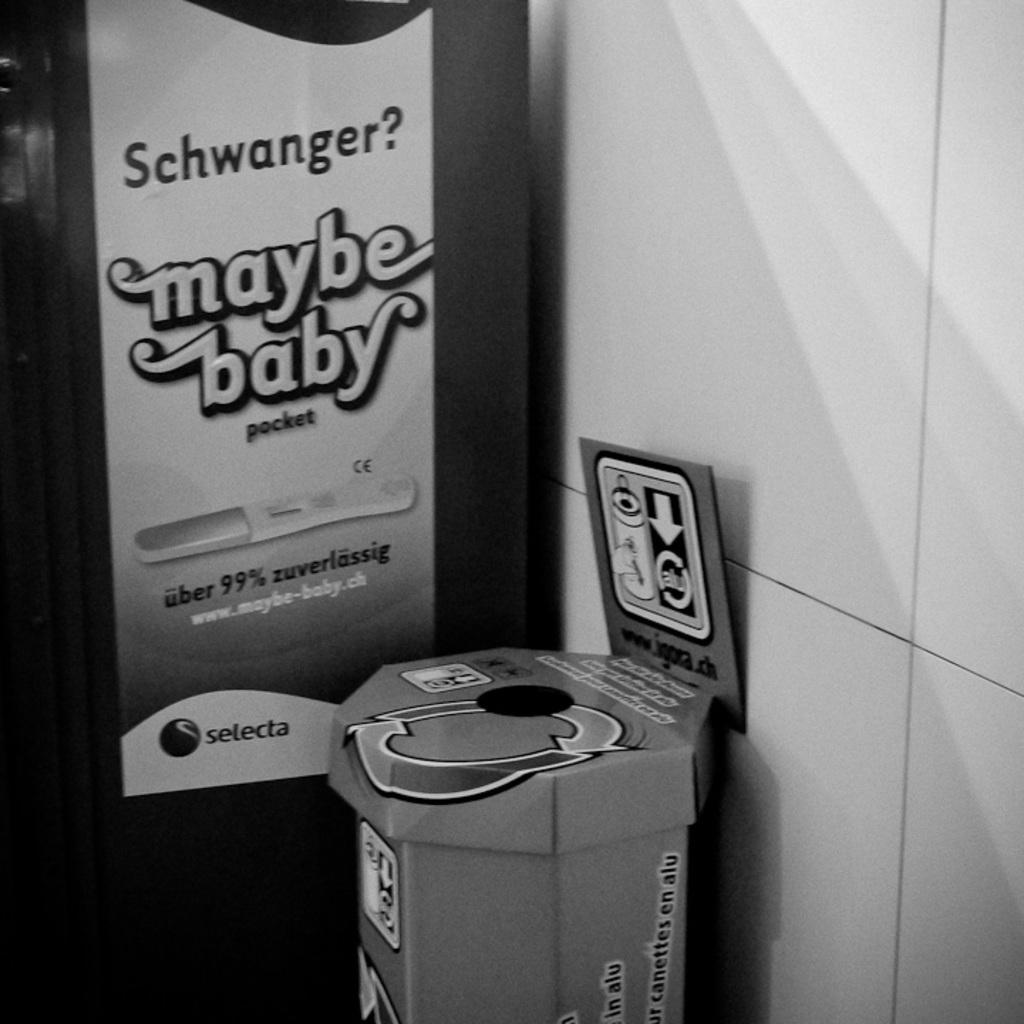<image>
Give a short and clear explanation of the subsequent image. An recycling can sits beside an ad for a pregnancy test. 